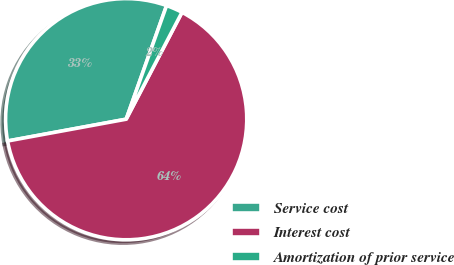Convert chart. <chart><loc_0><loc_0><loc_500><loc_500><pie_chart><fcel>Service cost<fcel>Interest cost<fcel>Amortization of prior service<nl><fcel>33.33%<fcel>64.44%<fcel>2.22%<nl></chart> 